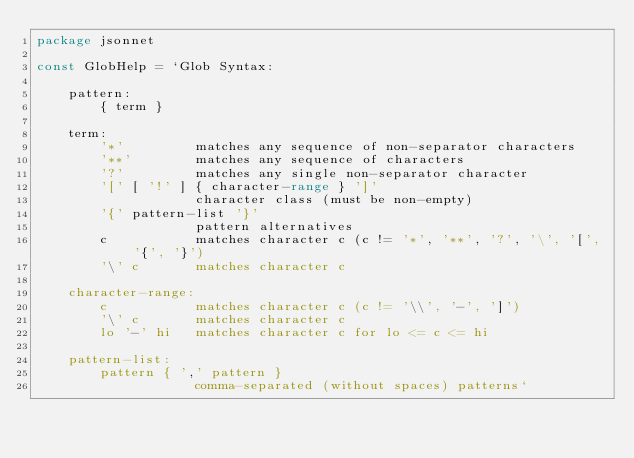<code> <loc_0><loc_0><loc_500><loc_500><_Go_>package jsonnet

const GlobHelp = `Glob Syntax:

    pattern:
        { term }

    term:
        '*'         matches any sequence of non-separator characters
        '**'        matches any sequence of characters
        '?'         matches any single non-separator character
        '[' [ '!' ] { character-range } ']'
                    character class (must be non-empty)
        '{' pattern-list '}'
                    pattern alternatives
        c           matches character c (c != '*', '**', '?', '\', '[', '{', '}')
        '\' c       matches character c

    character-range:
        c           matches character c (c != '\\', '-', ']')
        '\' c       matches character c
        lo '-' hi   matches character c for lo <= c <= hi

    pattern-list:
        pattern { ',' pattern }
                    comma-separated (without spaces) patterns`
</code> 